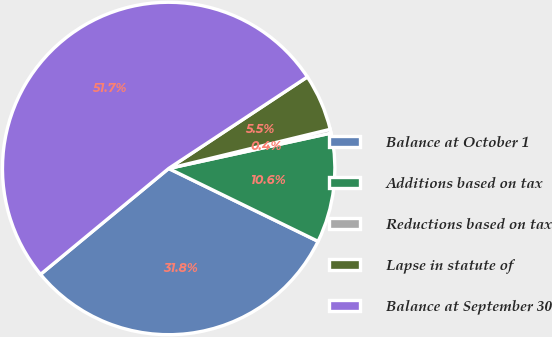Convert chart to OTSL. <chart><loc_0><loc_0><loc_500><loc_500><pie_chart><fcel>Balance at October 1<fcel>Additions based on tax<fcel>Reductions based on tax<fcel>Lapse in statute of<fcel>Balance at September 30<nl><fcel>31.79%<fcel>10.64%<fcel>0.37%<fcel>5.5%<fcel>51.71%<nl></chart> 